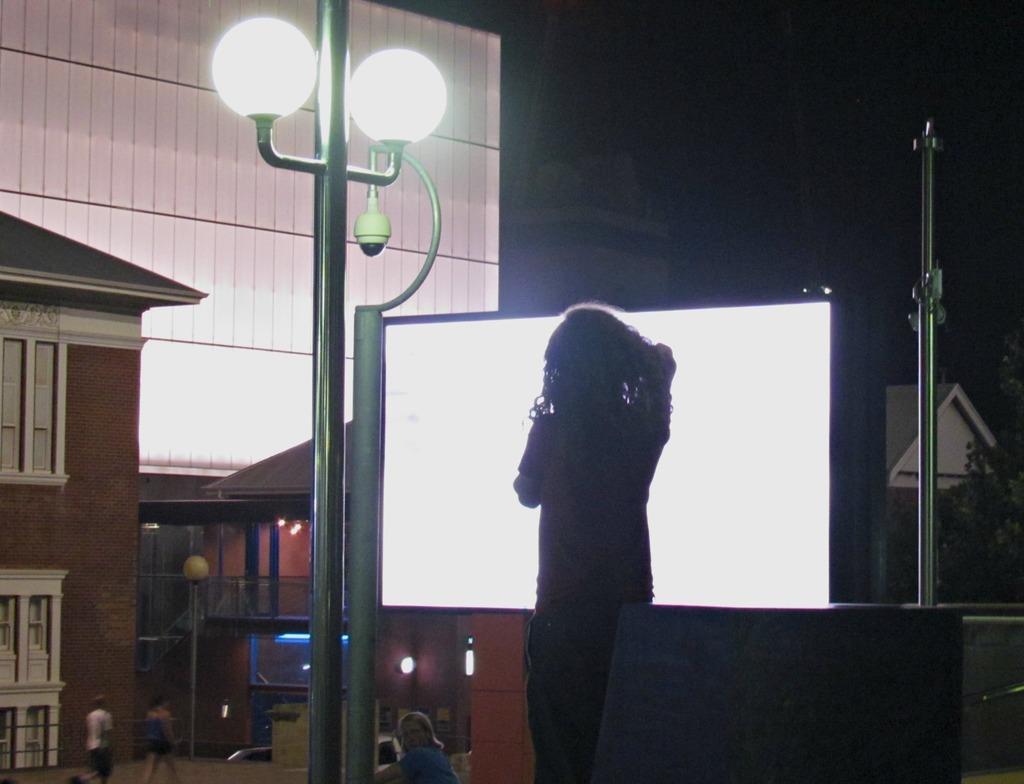Could you give a brief overview of what you see in this image? In this image, there are a few houses and people. We can see a screen and some poles. We can also see some trees on the right. We can see the ground and the dark sky. We can also see a white colored object. We can see some lights. 